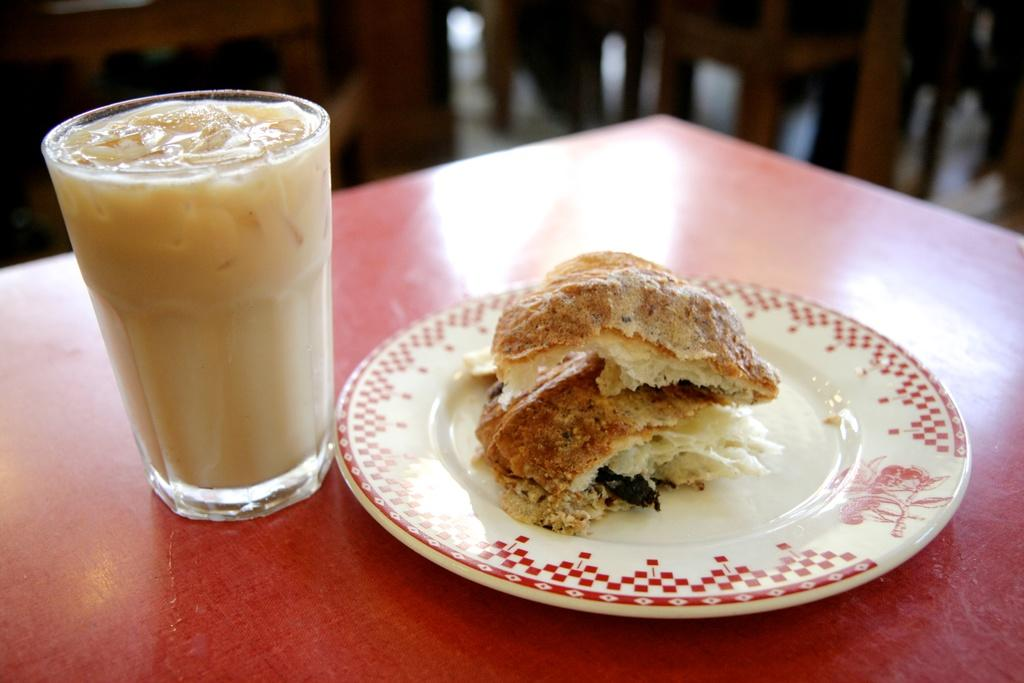What type of furniture is present in the image? There is a table in the image. What is the color of the table? The table is red in color. What is placed on the table? There is a plate on the table. What can be found on the plate? There are food items on the plate. What is located beside the table? There is a glass of milkshake beside the table. What type of roof can be seen in the image? There is no roof visible in the image. 